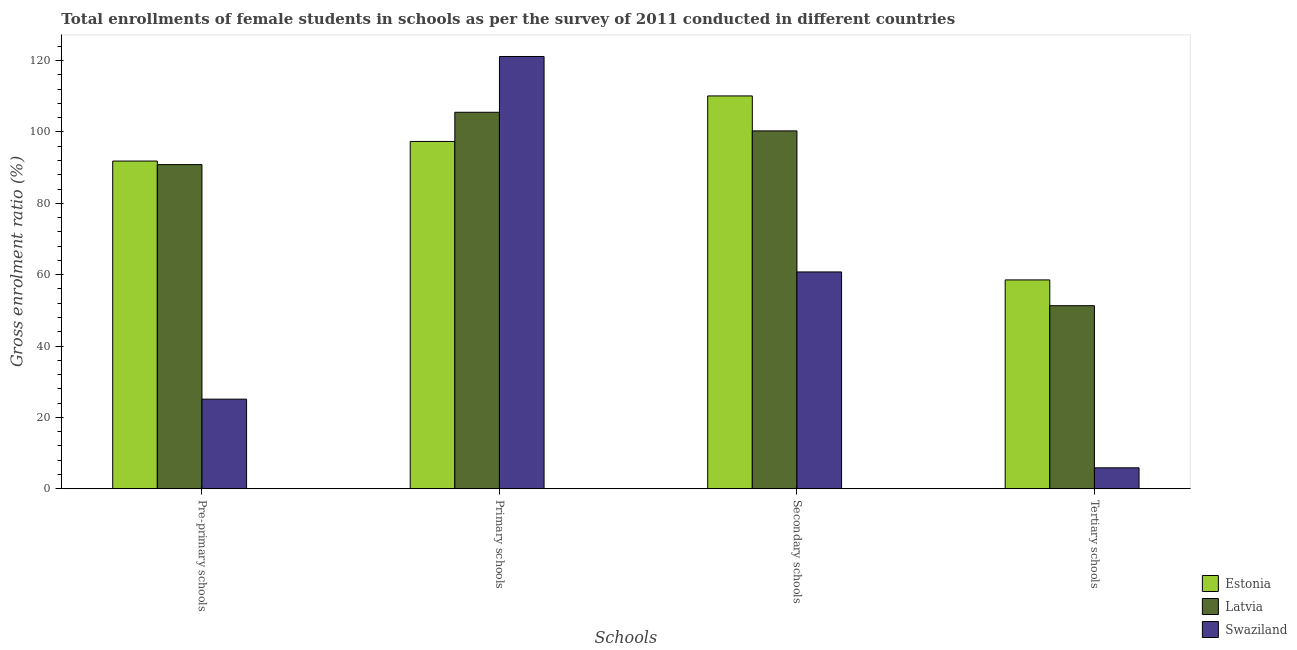How many different coloured bars are there?
Offer a terse response. 3. How many groups of bars are there?
Give a very brief answer. 4. Are the number of bars per tick equal to the number of legend labels?
Provide a succinct answer. Yes. How many bars are there on the 2nd tick from the left?
Your response must be concise. 3. What is the label of the 3rd group of bars from the left?
Give a very brief answer. Secondary schools. What is the gross enrolment ratio(female) in pre-primary schools in Latvia?
Your answer should be compact. 90.86. Across all countries, what is the maximum gross enrolment ratio(female) in pre-primary schools?
Keep it short and to the point. 91.85. Across all countries, what is the minimum gross enrolment ratio(female) in tertiary schools?
Provide a succinct answer. 5.84. In which country was the gross enrolment ratio(female) in primary schools maximum?
Keep it short and to the point. Swaziland. In which country was the gross enrolment ratio(female) in primary schools minimum?
Your answer should be compact. Estonia. What is the total gross enrolment ratio(female) in primary schools in the graph?
Your response must be concise. 324.05. What is the difference between the gross enrolment ratio(female) in secondary schools in Latvia and that in Swaziland?
Your answer should be very brief. 39.54. What is the difference between the gross enrolment ratio(female) in secondary schools in Latvia and the gross enrolment ratio(female) in primary schools in Estonia?
Ensure brevity in your answer.  2.95. What is the average gross enrolment ratio(female) in pre-primary schools per country?
Your answer should be very brief. 69.27. What is the difference between the gross enrolment ratio(female) in pre-primary schools and gross enrolment ratio(female) in primary schools in Estonia?
Offer a very short reply. -5.5. What is the ratio of the gross enrolment ratio(female) in tertiary schools in Estonia to that in Swaziland?
Your answer should be very brief. 10.02. Is the gross enrolment ratio(female) in tertiary schools in Latvia less than that in Swaziland?
Offer a terse response. No. What is the difference between the highest and the second highest gross enrolment ratio(female) in primary schools?
Your response must be concise. 15.64. What is the difference between the highest and the lowest gross enrolment ratio(female) in secondary schools?
Your answer should be very brief. 49.35. Is it the case that in every country, the sum of the gross enrolment ratio(female) in secondary schools and gross enrolment ratio(female) in tertiary schools is greater than the sum of gross enrolment ratio(female) in pre-primary schools and gross enrolment ratio(female) in primary schools?
Offer a very short reply. No. What does the 3rd bar from the left in Secondary schools represents?
Keep it short and to the point. Swaziland. What does the 1st bar from the right in Tertiary schools represents?
Your answer should be very brief. Swaziland. Is it the case that in every country, the sum of the gross enrolment ratio(female) in pre-primary schools and gross enrolment ratio(female) in primary schools is greater than the gross enrolment ratio(female) in secondary schools?
Make the answer very short. Yes. How many countries are there in the graph?
Offer a terse response. 3. What is the difference between two consecutive major ticks on the Y-axis?
Your answer should be very brief. 20. Are the values on the major ticks of Y-axis written in scientific E-notation?
Offer a very short reply. No. Does the graph contain any zero values?
Make the answer very short. No. Where does the legend appear in the graph?
Provide a succinct answer. Bottom right. How are the legend labels stacked?
Provide a short and direct response. Vertical. What is the title of the graph?
Offer a very short reply. Total enrollments of female students in schools as per the survey of 2011 conducted in different countries. Does "Togo" appear as one of the legend labels in the graph?
Provide a succinct answer. No. What is the label or title of the X-axis?
Ensure brevity in your answer.  Schools. What is the label or title of the Y-axis?
Offer a terse response. Gross enrolment ratio (%). What is the Gross enrolment ratio (%) in Estonia in Pre-primary schools?
Provide a short and direct response. 91.85. What is the Gross enrolment ratio (%) of Latvia in Pre-primary schools?
Offer a terse response. 90.86. What is the Gross enrolment ratio (%) of Swaziland in Pre-primary schools?
Provide a succinct answer. 25.1. What is the Gross enrolment ratio (%) of Estonia in Primary schools?
Your answer should be compact. 97.35. What is the Gross enrolment ratio (%) of Latvia in Primary schools?
Offer a terse response. 105.53. What is the Gross enrolment ratio (%) of Swaziland in Primary schools?
Provide a short and direct response. 121.17. What is the Gross enrolment ratio (%) in Estonia in Secondary schools?
Provide a short and direct response. 110.11. What is the Gross enrolment ratio (%) in Latvia in Secondary schools?
Offer a terse response. 100.31. What is the Gross enrolment ratio (%) in Swaziland in Secondary schools?
Give a very brief answer. 60.77. What is the Gross enrolment ratio (%) of Estonia in Tertiary schools?
Give a very brief answer. 58.53. What is the Gross enrolment ratio (%) in Latvia in Tertiary schools?
Ensure brevity in your answer.  51.3. What is the Gross enrolment ratio (%) of Swaziland in Tertiary schools?
Provide a succinct answer. 5.84. Across all Schools, what is the maximum Gross enrolment ratio (%) of Estonia?
Provide a succinct answer. 110.11. Across all Schools, what is the maximum Gross enrolment ratio (%) of Latvia?
Your answer should be very brief. 105.53. Across all Schools, what is the maximum Gross enrolment ratio (%) in Swaziland?
Ensure brevity in your answer.  121.17. Across all Schools, what is the minimum Gross enrolment ratio (%) of Estonia?
Offer a very short reply. 58.53. Across all Schools, what is the minimum Gross enrolment ratio (%) of Latvia?
Your answer should be very brief. 51.3. Across all Schools, what is the minimum Gross enrolment ratio (%) in Swaziland?
Ensure brevity in your answer.  5.84. What is the total Gross enrolment ratio (%) in Estonia in the graph?
Ensure brevity in your answer.  357.85. What is the total Gross enrolment ratio (%) of Latvia in the graph?
Ensure brevity in your answer.  347.99. What is the total Gross enrolment ratio (%) of Swaziland in the graph?
Your answer should be compact. 212.88. What is the difference between the Gross enrolment ratio (%) in Estonia in Pre-primary schools and that in Primary schools?
Your answer should be compact. -5.5. What is the difference between the Gross enrolment ratio (%) of Latvia in Pre-primary schools and that in Primary schools?
Your answer should be very brief. -14.67. What is the difference between the Gross enrolment ratio (%) of Swaziland in Pre-primary schools and that in Primary schools?
Provide a short and direct response. -96.07. What is the difference between the Gross enrolment ratio (%) in Estonia in Pre-primary schools and that in Secondary schools?
Make the answer very short. -18.26. What is the difference between the Gross enrolment ratio (%) in Latvia in Pre-primary schools and that in Secondary schools?
Your answer should be very brief. -9.45. What is the difference between the Gross enrolment ratio (%) of Swaziland in Pre-primary schools and that in Secondary schools?
Your answer should be very brief. -35.67. What is the difference between the Gross enrolment ratio (%) in Estonia in Pre-primary schools and that in Tertiary schools?
Make the answer very short. 33.32. What is the difference between the Gross enrolment ratio (%) of Latvia in Pre-primary schools and that in Tertiary schools?
Ensure brevity in your answer.  39.56. What is the difference between the Gross enrolment ratio (%) of Swaziland in Pre-primary schools and that in Tertiary schools?
Offer a very short reply. 19.26. What is the difference between the Gross enrolment ratio (%) of Estonia in Primary schools and that in Secondary schools?
Offer a very short reply. -12.76. What is the difference between the Gross enrolment ratio (%) of Latvia in Primary schools and that in Secondary schools?
Your answer should be compact. 5.22. What is the difference between the Gross enrolment ratio (%) in Swaziland in Primary schools and that in Secondary schools?
Keep it short and to the point. 60.41. What is the difference between the Gross enrolment ratio (%) in Estonia in Primary schools and that in Tertiary schools?
Your answer should be compact. 38.82. What is the difference between the Gross enrolment ratio (%) in Latvia in Primary schools and that in Tertiary schools?
Your answer should be compact. 54.23. What is the difference between the Gross enrolment ratio (%) of Swaziland in Primary schools and that in Tertiary schools?
Your response must be concise. 115.33. What is the difference between the Gross enrolment ratio (%) in Estonia in Secondary schools and that in Tertiary schools?
Your response must be concise. 51.58. What is the difference between the Gross enrolment ratio (%) of Latvia in Secondary schools and that in Tertiary schools?
Offer a terse response. 49.01. What is the difference between the Gross enrolment ratio (%) of Swaziland in Secondary schools and that in Tertiary schools?
Ensure brevity in your answer.  54.92. What is the difference between the Gross enrolment ratio (%) in Estonia in Pre-primary schools and the Gross enrolment ratio (%) in Latvia in Primary schools?
Make the answer very short. -13.68. What is the difference between the Gross enrolment ratio (%) of Estonia in Pre-primary schools and the Gross enrolment ratio (%) of Swaziland in Primary schools?
Make the answer very short. -29.32. What is the difference between the Gross enrolment ratio (%) in Latvia in Pre-primary schools and the Gross enrolment ratio (%) in Swaziland in Primary schools?
Provide a succinct answer. -30.31. What is the difference between the Gross enrolment ratio (%) of Estonia in Pre-primary schools and the Gross enrolment ratio (%) of Latvia in Secondary schools?
Your answer should be very brief. -8.46. What is the difference between the Gross enrolment ratio (%) of Estonia in Pre-primary schools and the Gross enrolment ratio (%) of Swaziland in Secondary schools?
Ensure brevity in your answer.  31.09. What is the difference between the Gross enrolment ratio (%) in Latvia in Pre-primary schools and the Gross enrolment ratio (%) in Swaziland in Secondary schools?
Provide a short and direct response. 30.09. What is the difference between the Gross enrolment ratio (%) of Estonia in Pre-primary schools and the Gross enrolment ratio (%) of Latvia in Tertiary schools?
Ensure brevity in your answer.  40.55. What is the difference between the Gross enrolment ratio (%) of Estonia in Pre-primary schools and the Gross enrolment ratio (%) of Swaziland in Tertiary schools?
Offer a very short reply. 86.01. What is the difference between the Gross enrolment ratio (%) in Latvia in Pre-primary schools and the Gross enrolment ratio (%) in Swaziland in Tertiary schools?
Provide a succinct answer. 85.01. What is the difference between the Gross enrolment ratio (%) in Estonia in Primary schools and the Gross enrolment ratio (%) in Latvia in Secondary schools?
Offer a terse response. -2.95. What is the difference between the Gross enrolment ratio (%) of Estonia in Primary schools and the Gross enrolment ratio (%) of Swaziland in Secondary schools?
Ensure brevity in your answer.  36.59. What is the difference between the Gross enrolment ratio (%) in Latvia in Primary schools and the Gross enrolment ratio (%) in Swaziland in Secondary schools?
Make the answer very short. 44.76. What is the difference between the Gross enrolment ratio (%) of Estonia in Primary schools and the Gross enrolment ratio (%) of Latvia in Tertiary schools?
Offer a very short reply. 46.05. What is the difference between the Gross enrolment ratio (%) in Estonia in Primary schools and the Gross enrolment ratio (%) in Swaziland in Tertiary schools?
Make the answer very short. 91.51. What is the difference between the Gross enrolment ratio (%) of Latvia in Primary schools and the Gross enrolment ratio (%) of Swaziland in Tertiary schools?
Your answer should be very brief. 99.68. What is the difference between the Gross enrolment ratio (%) of Estonia in Secondary schools and the Gross enrolment ratio (%) of Latvia in Tertiary schools?
Provide a succinct answer. 58.81. What is the difference between the Gross enrolment ratio (%) in Estonia in Secondary schools and the Gross enrolment ratio (%) in Swaziland in Tertiary schools?
Your answer should be very brief. 104.27. What is the difference between the Gross enrolment ratio (%) in Latvia in Secondary schools and the Gross enrolment ratio (%) in Swaziland in Tertiary schools?
Give a very brief answer. 94.46. What is the average Gross enrolment ratio (%) in Estonia per Schools?
Give a very brief answer. 89.46. What is the average Gross enrolment ratio (%) in Latvia per Schools?
Provide a succinct answer. 87. What is the average Gross enrolment ratio (%) in Swaziland per Schools?
Your response must be concise. 53.22. What is the difference between the Gross enrolment ratio (%) in Estonia and Gross enrolment ratio (%) in Swaziland in Pre-primary schools?
Ensure brevity in your answer.  66.75. What is the difference between the Gross enrolment ratio (%) in Latvia and Gross enrolment ratio (%) in Swaziland in Pre-primary schools?
Ensure brevity in your answer.  65.76. What is the difference between the Gross enrolment ratio (%) in Estonia and Gross enrolment ratio (%) in Latvia in Primary schools?
Offer a terse response. -8.18. What is the difference between the Gross enrolment ratio (%) of Estonia and Gross enrolment ratio (%) of Swaziland in Primary schools?
Your response must be concise. -23.82. What is the difference between the Gross enrolment ratio (%) of Latvia and Gross enrolment ratio (%) of Swaziland in Primary schools?
Your answer should be compact. -15.64. What is the difference between the Gross enrolment ratio (%) in Estonia and Gross enrolment ratio (%) in Latvia in Secondary schools?
Keep it short and to the point. 9.81. What is the difference between the Gross enrolment ratio (%) in Estonia and Gross enrolment ratio (%) in Swaziland in Secondary schools?
Make the answer very short. 49.35. What is the difference between the Gross enrolment ratio (%) in Latvia and Gross enrolment ratio (%) in Swaziland in Secondary schools?
Your response must be concise. 39.54. What is the difference between the Gross enrolment ratio (%) of Estonia and Gross enrolment ratio (%) of Latvia in Tertiary schools?
Your answer should be very brief. 7.23. What is the difference between the Gross enrolment ratio (%) in Estonia and Gross enrolment ratio (%) in Swaziland in Tertiary schools?
Offer a very short reply. 52.69. What is the difference between the Gross enrolment ratio (%) in Latvia and Gross enrolment ratio (%) in Swaziland in Tertiary schools?
Your answer should be compact. 45.46. What is the ratio of the Gross enrolment ratio (%) in Estonia in Pre-primary schools to that in Primary schools?
Your answer should be very brief. 0.94. What is the ratio of the Gross enrolment ratio (%) in Latvia in Pre-primary schools to that in Primary schools?
Keep it short and to the point. 0.86. What is the ratio of the Gross enrolment ratio (%) of Swaziland in Pre-primary schools to that in Primary schools?
Keep it short and to the point. 0.21. What is the ratio of the Gross enrolment ratio (%) in Estonia in Pre-primary schools to that in Secondary schools?
Give a very brief answer. 0.83. What is the ratio of the Gross enrolment ratio (%) in Latvia in Pre-primary schools to that in Secondary schools?
Make the answer very short. 0.91. What is the ratio of the Gross enrolment ratio (%) in Swaziland in Pre-primary schools to that in Secondary schools?
Make the answer very short. 0.41. What is the ratio of the Gross enrolment ratio (%) in Estonia in Pre-primary schools to that in Tertiary schools?
Make the answer very short. 1.57. What is the ratio of the Gross enrolment ratio (%) in Latvia in Pre-primary schools to that in Tertiary schools?
Make the answer very short. 1.77. What is the ratio of the Gross enrolment ratio (%) in Swaziland in Pre-primary schools to that in Tertiary schools?
Offer a very short reply. 4.3. What is the ratio of the Gross enrolment ratio (%) of Estonia in Primary schools to that in Secondary schools?
Provide a succinct answer. 0.88. What is the ratio of the Gross enrolment ratio (%) of Latvia in Primary schools to that in Secondary schools?
Make the answer very short. 1.05. What is the ratio of the Gross enrolment ratio (%) in Swaziland in Primary schools to that in Secondary schools?
Your answer should be compact. 1.99. What is the ratio of the Gross enrolment ratio (%) of Estonia in Primary schools to that in Tertiary schools?
Provide a short and direct response. 1.66. What is the ratio of the Gross enrolment ratio (%) in Latvia in Primary schools to that in Tertiary schools?
Offer a terse response. 2.06. What is the ratio of the Gross enrolment ratio (%) in Swaziland in Primary schools to that in Tertiary schools?
Your answer should be compact. 20.74. What is the ratio of the Gross enrolment ratio (%) of Estonia in Secondary schools to that in Tertiary schools?
Your response must be concise. 1.88. What is the ratio of the Gross enrolment ratio (%) in Latvia in Secondary schools to that in Tertiary schools?
Offer a very short reply. 1.96. What is the ratio of the Gross enrolment ratio (%) of Swaziland in Secondary schools to that in Tertiary schools?
Offer a terse response. 10.4. What is the difference between the highest and the second highest Gross enrolment ratio (%) in Estonia?
Provide a succinct answer. 12.76. What is the difference between the highest and the second highest Gross enrolment ratio (%) of Latvia?
Your answer should be very brief. 5.22. What is the difference between the highest and the second highest Gross enrolment ratio (%) in Swaziland?
Ensure brevity in your answer.  60.41. What is the difference between the highest and the lowest Gross enrolment ratio (%) of Estonia?
Keep it short and to the point. 51.58. What is the difference between the highest and the lowest Gross enrolment ratio (%) in Latvia?
Ensure brevity in your answer.  54.23. What is the difference between the highest and the lowest Gross enrolment ratio (%) in Swaziland?
Your response must be concise. 115.33. 